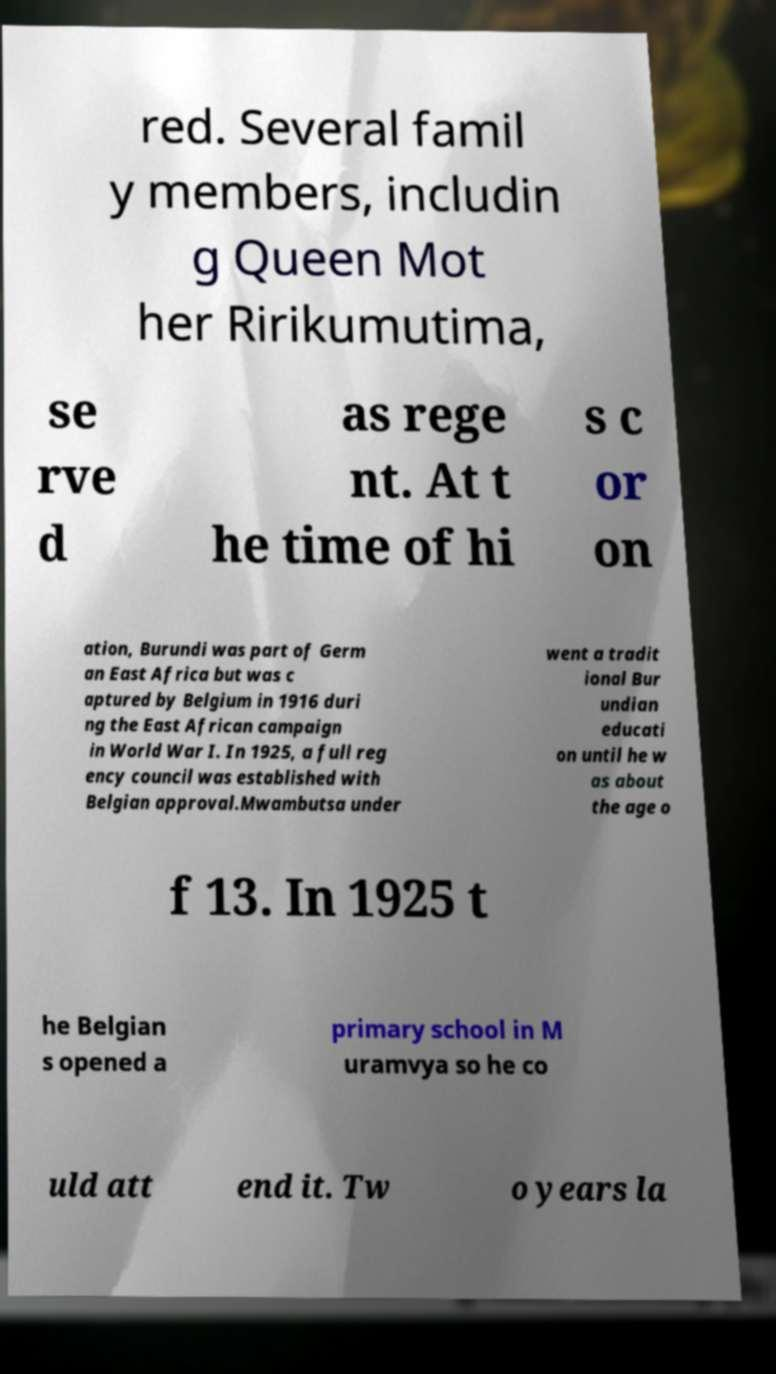There's text embedded in this image that I need extracted. Can you transcribe it verbatim? red. Several famil y members, includin g Queen Mot her Ririkumutima, se rve d as rege nt. At t he time of hi s c or on ation, Burundi was part of Germ an East Africa but was c aptured by Belgium in 1916 duri ng the East African campaign in World War I. In 1925, a full reg ency council was established with Belgian approval.Mwambutsa under went a tradit ional Bur undian educati on until he w as about the age o f 13. In 1925 t he Belgian s opened a primary school in M uramvya so he co uld att end it. Tw o years la 